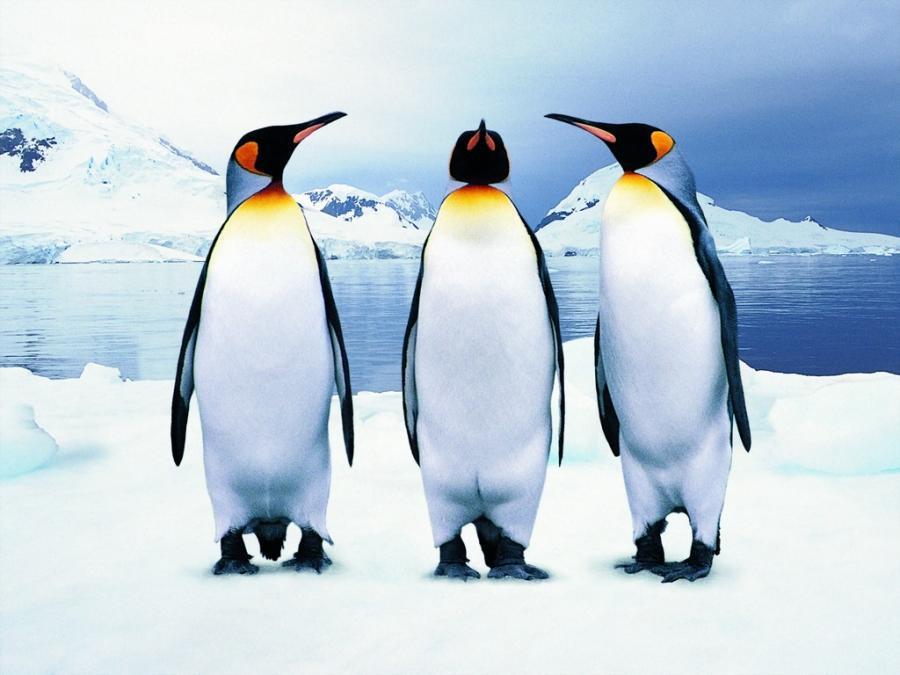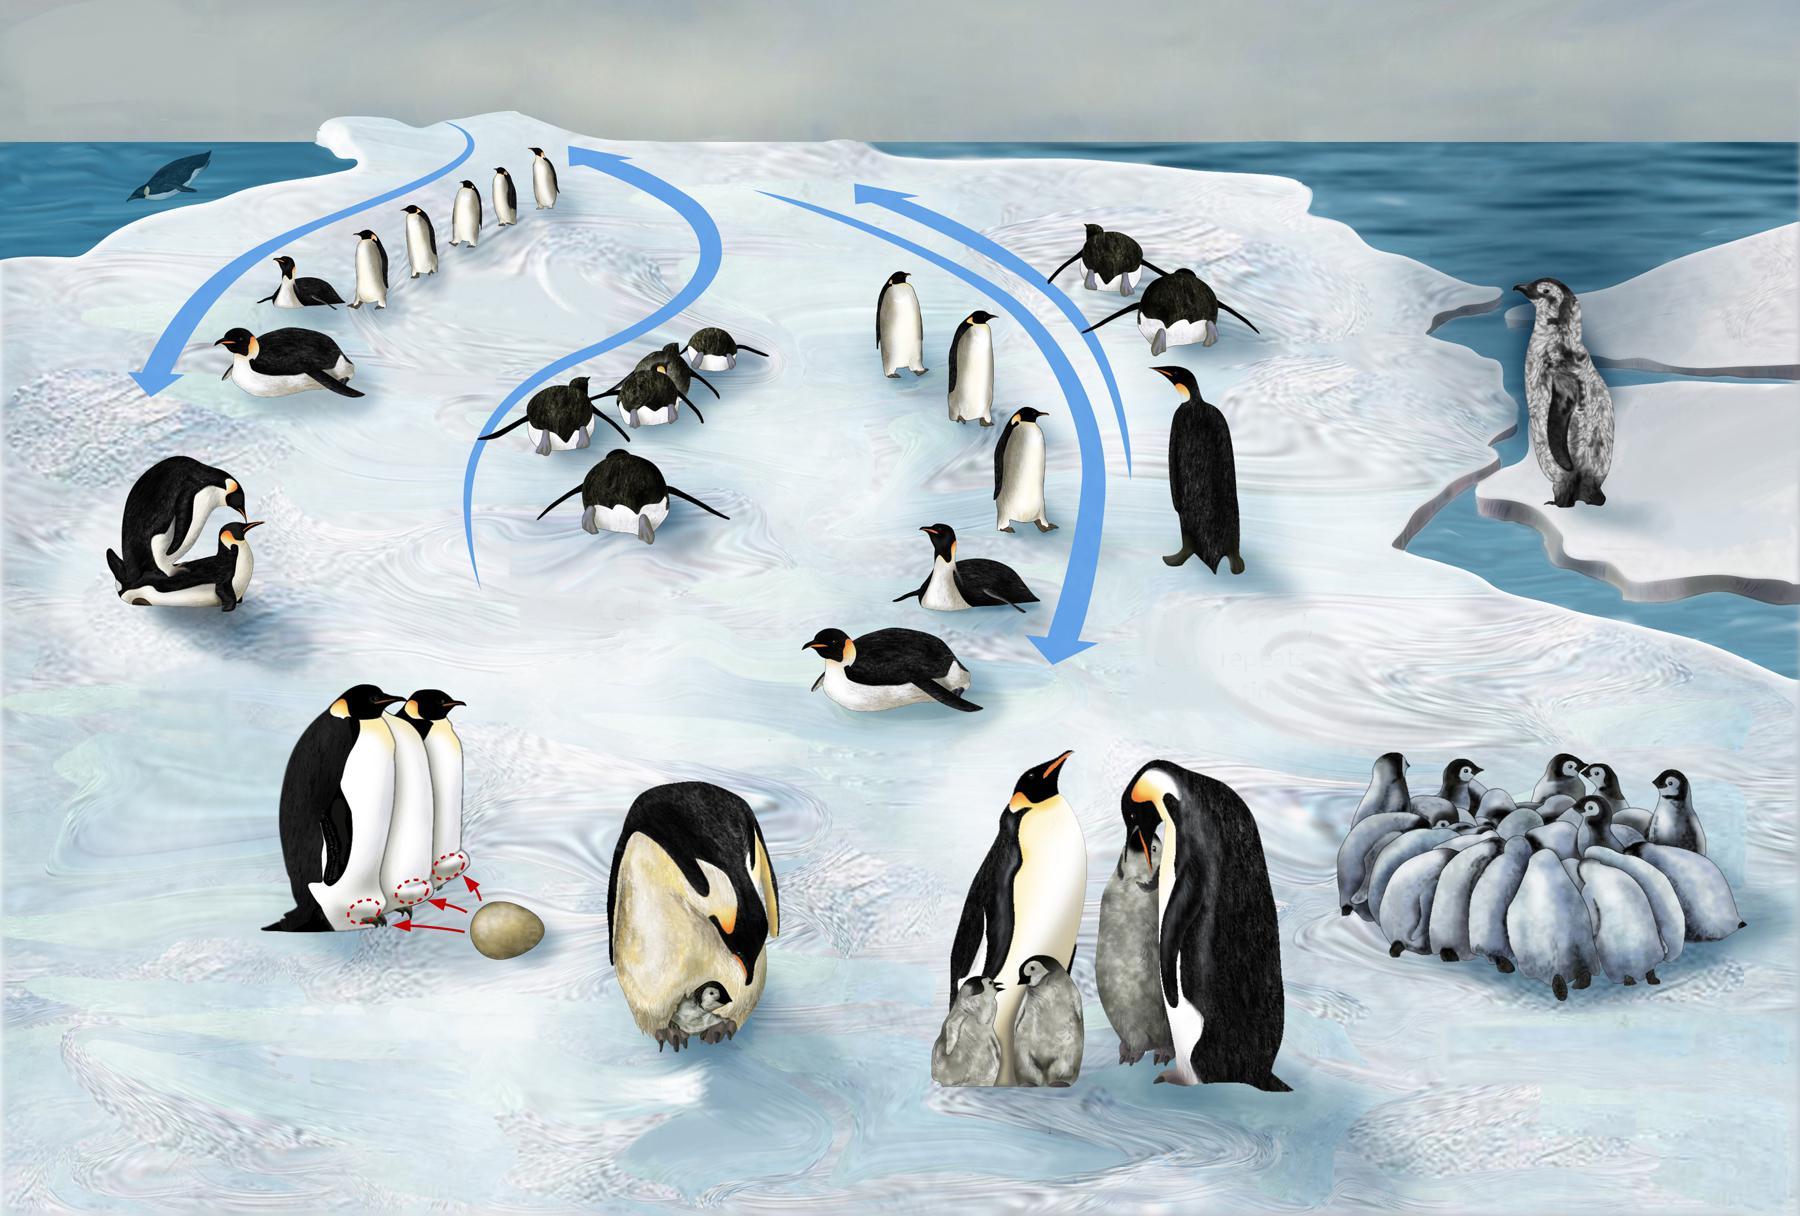The first image is the image on the left, the second image is the image on the right. For the images shown, is this caption "One of the images depicts exactly three penguins." true? Answer yes or no. Yes. 